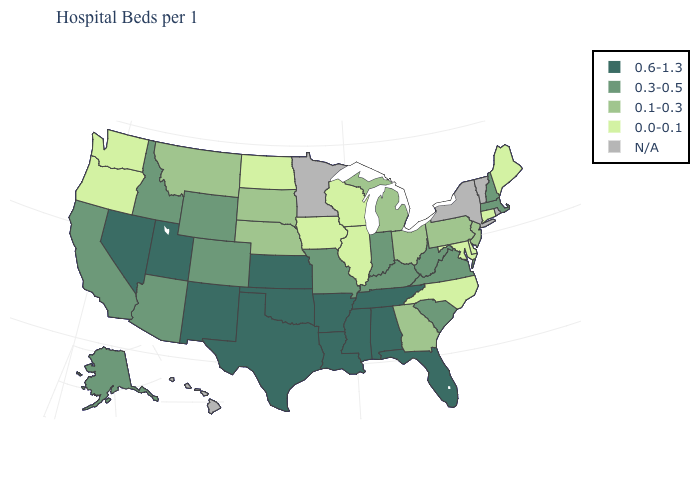What is the lowest value in states that border Oregon?
Quick response, please. 0.0-0.1. What is the value of Arizona?
Concise answer only. 0.3-0.5. Is the legend a continuous bar?
Give a very brief answer. No. Among the states that border Florida , which have the highest value?
Answer briefly. Alabama. Name the states that have a value in the range 0.1-0.3?
Concise answer only. Georgia, Michigan, Montana, Nebraska, New Jersey, Ohio, Pennsylvania, South Dakota. What is the value of Mississippi?
Give a very brief answer. 0.6-1.3. Name the states that have a value in the range N/A?
Concise answer only. Hawaii, Minnesota, New York, Rhode Island, Vermont. Name the states that have a value in the range 0.6-1.3?
Quick response, please. Alabama, Arkansas, Florida, Kansas, Louisiana, Mississippi, Nevada, New Mexico, Oklahoma, Tennessee, Texas, Utah. Does the map have missing data?
Give a very brief answer. Yes. Name the states that have a value in the range 0.1-0.3?
Keep it brief. Georgia, Michigan, Montana, Nebraska, New Jersey, Ohio, Pennsylvania, South Dakota. What is the value of Massachusetts?
Concise answer only. 0.3-0.5. Which states hav the highest value in the MidWest?
Answer briefly. Kansas. 